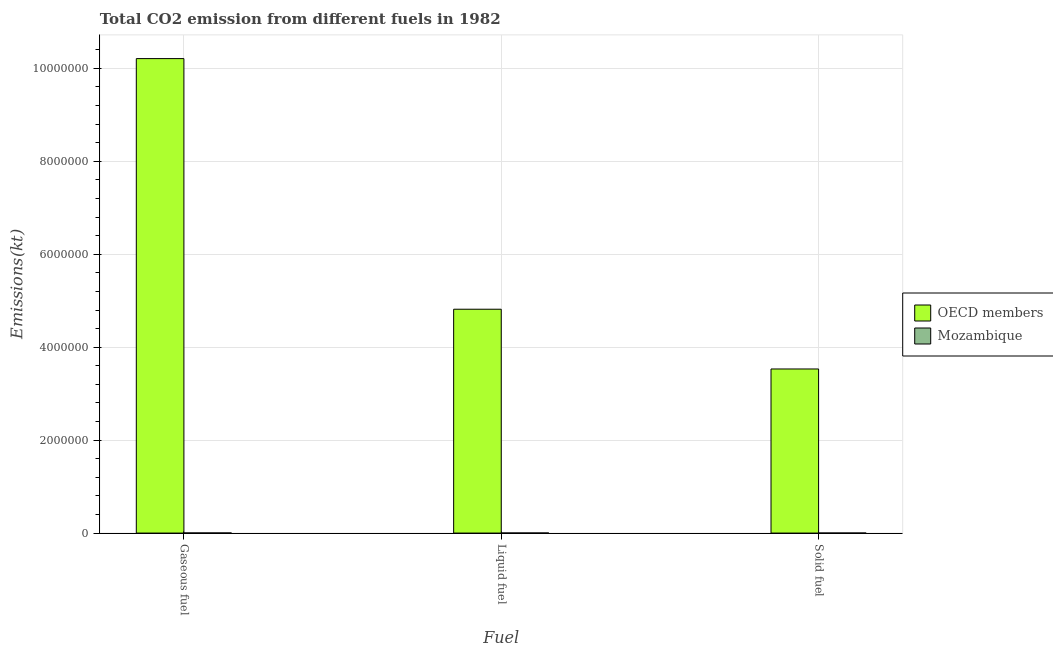How many groups of bars are there?
Your response must be concise. 3. Are the number of bars per tick equal to the number of legend labels?
Offer a terse response. Yes. Are the number of bars on each tick of the X-axis equal?
Your answer should be compact. Yes. How many bars are there on the 1st tick from the left?
Provide a short and direct response. 2. How many bars are there on the 1st tick from the right?
Offer a very short reply. 2. What is the label of the 3rd group of bars from the left?
Give a very brief answer. Solid fuel. What is the amount of co2 emissions from gaseous fuel in Mozambique?
Keep it short and to the point. 2541.23. Across all countries, what is the maximum amount of co2 emissions from solid fuel?
Keep it short and to the point. 3.53e+06. Across all countries, what is the minimum amount of co2 emissions from solid fuel?
Offer a terse response. 645.39. In which country was the amount of co2 emissions from solid fuel minimum?
Give a very brief answer. Mozambique. What is the total amount of co2 emissions from liquid fuel in the graph?
Your response must be concise. 4.82e+06. What is the difference between the amount of co2 emissions from gaseous fuel in Mozambique and that in OECD members?
Your answer should be compact. -1.02e+07. What is the difference between the amount of co2 emissions from solid fuel in Mozambique and the amount of co2 emissions from liquid fuel in OECD members?
Offer a very short reply. -4.82e+06. What is the average amount of co2 emissions from liquid fuel per country?
Keep it short and to the point. 2.41e+06. What is the difference between the amount of co2 emissions from solid fuel and amount of co2 emissions from gaseous fuel in Mozambique?
Make the answer very short. -1895.84. What is the ratio of the amount of co2 emissions from liquid fuel in OECD members to that in Mozambique?
Your response must be concise. 2800.88. Is the difference between the amount of co2 emissions from gaseous fuel in Mozambique and OECD members greater than the difference between the amount of co2 emissions from solid fuel in Mozambique and OECD members?
Provide a short and direct response. No. What is the difference between the highest and the second highest amount of co2 emissions from gaseous fuel?
Ensure brevity in your answer.  1.02e+07. What is the difference between the highest and the lowest amount of co2 emissions from liquid fuel?
Your answer should be compact. 4.82e+06. Is the sum of the amount of co2 emissions from liquid fuel in Mozambique and OECD members greater than the maximum amount of co2 emissions from gaseous fuel across all countries?
Give a very brief answer. No. What does the 1st bar from the right in Liquid fuel represents?
Provide a succinct answer. Mozambique. How many countries are there in the graph?
Provide a short and direct response. 2. Are the values on the major ticks of Y-axis written in scientific E-notation?
Ensure brevity in your answer.  No. Where does the legend appear in the graph?
Offer a terse response. Center right. How many legend labels are there?
Your answer should be compact. 2. What is the title of the graph?
Offer a very short reply. Total CO2 emission from different fuels in 1982. What is the label or title of the X-axis?
Offer a very short reply. Fuel. What is the label or title of the Y-axis?
Your answer should be very brief. Emissions(kt). What is the Emissions(kt) in OECD members in Gaseous fuel?
Keep it short and to the point. 1.02e+07. What is the Emissions(kt) in Mozambique in Gaseous fuel?
Your answer should be very brief. 2541.23. What is the Emissions(kt) in OECD members in Liquid fuel?
Your answer should be very brief. 4.82e+06. What is the Emissions(kt) in Mozambique in Liquid fuel?
Offer a very short reply. 1719.82. What is the Emissions(kt) in OECD members in Solid fuel?
Your answer should be very brief. 3.53e+06. What is the Emissions(kt) of Mozambique in Solid fuel?
Keep it short and to the point. 645.39. Across all Fuel, what is the maximum Emissions(kt) in OECD members?
Provide a short and direct response. 1.02e+07. Across all Fuel, what is the maximum Emissions(kt) in Mozambique?
Offer a terse response. 2541.23. Across all Fuel, what is the minimum Emissions(kt) of OECD members?
Keep it short and to the point. 3.53e+06. Across all Fuel, what is the minimum Emissions(kt) of Mozambique?
Your answer should be compact. 645.39. What is the total Emissions(kt) of OECD members in the graph?
Provide a short and direct response. 1.86e+07. What is the total Emissions(kt) of Mozambique in the graph?
Provide a short and direct response. 4906.45. What is the difference between the Emissions(kt) of OECD members in Gaseous fuel and that in Liquid fuel?
Your answer should be very brief. 5.39e+06. What is the difference between the Emissions(kt) of Mozambique in Gaseous fuel and that in Liquid fuel?
Make the answer very short. 821.41. What is the difference between the Emissions(kt) in OECD members in Gaseous fuel and that in Solid fuel?
Give a very brief answer. 6.68e+06. What is the difference between the Emissions(kt) of Mozambique in Gaseous fuel and that in Solid fuel?
Offer a terse response. 1895.84. What is the difference between the Emissions(kt) in OECD members in Liquid fuel and that in Solid fuel?
Keep it short and to the point. 1.29e+06. What is the difference between the Emissions(kt) of Mozambique in Liquid fuel and that in Solid fuel?
Make the answer very short. 1074.43. What is the difference between the Emissions(kt) in OECD members in Gaseous fuel and the Emissions(kt) in Mozambique in Liquid fuel?
Your answer should be very brief. 1.02e+07. What is the difference between the Emissions(kt) of OECD members in Gaseous fuel and the Emissions(kt) of Mozambique in Solid fuel?
Your response must be concise. 1.02e+07. What is the difference between the Emissions(kt) of OECD members in Liquid fuel and the Emissions(kt) of Mozambique in Solid fuel?
Offer a terse response. 4.82e+06. What is the average Emissions(kt) in OECD members per Fuel?
Your answer should be very brief. 6.19e+06. What is the average Emissions(kt) of Mozambique per Fuel?
Ensure brevity in your answer.  1635.48. What is the difference between the Emissions(kt) in OECD members and Emissions(kt) in Mozambique in Gaseous fuel?
Your answer should be very brief. 1.02e+07. What is the difference between the Emissions(kt) of OECD members and Emissions(kt) of Mozambique in Liquid fuel?
Give a very brief answer. 4.82e+06. What is the difference between the Emissions(kt) in OECD members and Emissions(kt) in Mozambique in Solid fuel?
Provide a succinct answer. 3.53e+06. What is the ratio of the Emissions(kt) of OECD members in Gaseous fuel to that in Liquid fuel?
Ensure brevity in your answer.  2.12. What is the ratio of the Emissions(kt) in Mozambique in Gaseous fuel to that in Liquid fuel?
Keep it short and to the point. 1.48. What is the ratio of the Emissions(kt) in OECD members in Gaseous fuel to that in Solid fuel?
Keep it short and to the point. 2.89. What is the ratio of the Emissions(kt) in Mozambique in Gaseous fuel to that in Solid fuel?
Your answer should be very brief. 3.94. What is the ratio of the Emissions(kt) in OECD members in Liquid fuel to that in Solid fuel?
Provide a succinct answer. 1.36. What is the ratio of the Emissions(kt) in Mozambique in Liquid fuel to that in Solid fuel?
Offer a very short reply. 2.66. What is the difference between the highest and the second highest Emissions(kt) in OECD members?
Your response must be concise. 5.39e+06. What is the difference between the highest and the second highest Emissions(kt) of Mozambique?
Ensure brevity in your answer.  821.41. What is the difference between the highest and the lowest Emissions(kt) of OECD members?
Provide a short and direct response. 6.68e+06. What is the difference between the highest and the lowest Emissions(kt) in Mozambique?
Ensure brevity in your answer.  1895.84. 